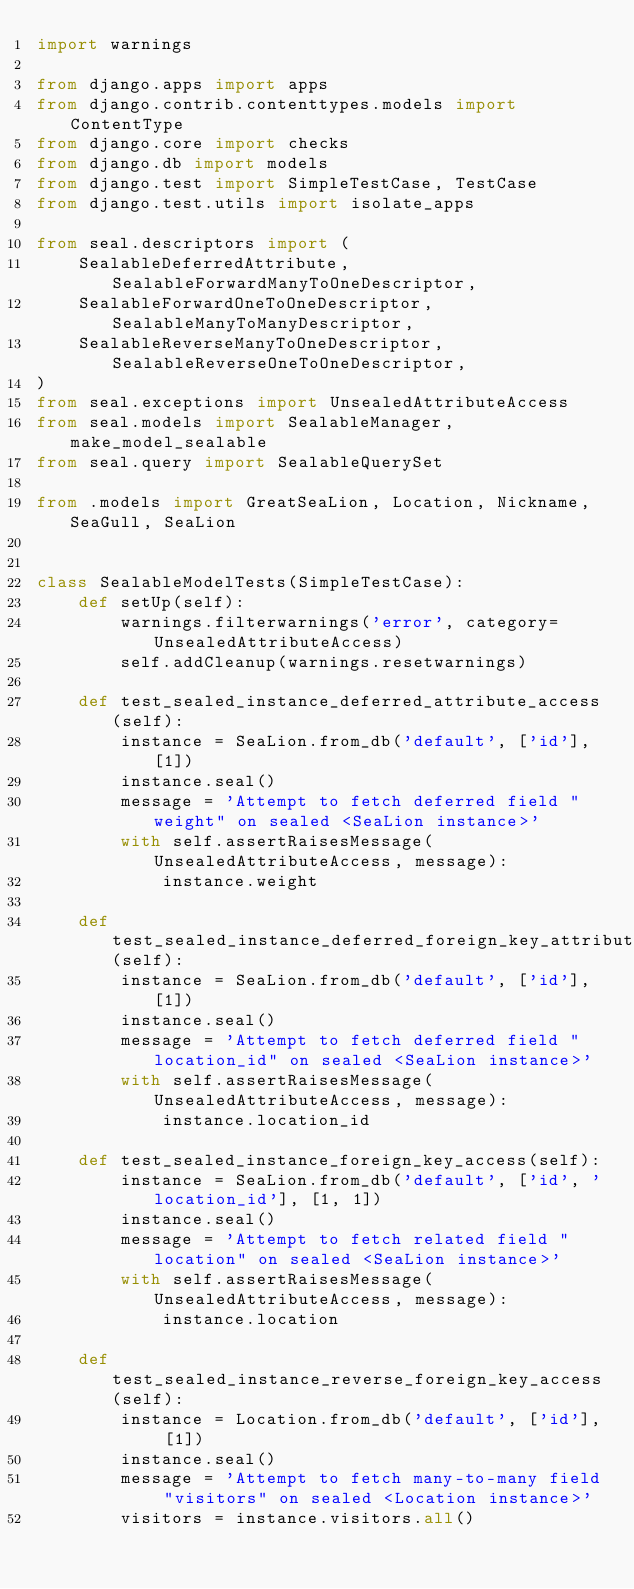<code> <loc_0><loc_0><loc_500><loc_500><_Python_>import warnings

from django.apps import apps
from django.contrib.contenttypes.models import ContentType
from django.core import checks
from django.db import models
from django.test import SimpleTestCase, TestCase
from django.test.utils import isolate_apps

from seal.descriptors import (
    SealableDeferredAttribute, SealableForwardManyToOneDescriptor,
    SealableForwardOneToOneDescriptor, SealableManyToManyDescriptor,
    SealableReverseManyToOneDescriptor, SealableReverseOneToOneDescriptor,
)
from seal.exceptions import UnsealedAttributeAccess
from seal.models import SealableManager, make_model_sealable
from seal.query import SealableQuerySet

from .models import GreatSeaLion, Location, Nickname, SeaGull, SeaLion


class SealableModelTests(SimpleTestCase):
    def setUp(self):
        warnings.filterwarnings('error', category=UnsealedAttributeAccess)
        self.addCleanup(warnings.resetwarnings)

    def test_sealed_instance_deferred_attribute_access(self):
        instance = SeaLion.from_db('default', ['id'], [1])
        instance.seal()
        message = 'Attempt to fetch deferred field "weight" on sealed <SeaLion instance>'
        with self.assertRaisesMessage(UnsealedAttributeAccess, message):
            instance.weight

    def test_sealed_instance_deferred_foreign_key_attribute_access(self):
        instance = SeaLion.from_db('default', ['id'], [1])
        instance.seal()
        message = 'Attempt to fetch deferred field "location_id" on sealed <SeaLion instance>'
        with self.assertRaisesMessage(UnsealedAttributeAccess, message):
            instance.location_id

    def test_sealed_instance_foreign_key_access(self):
        instance = SeaLion.from_db('default', ['id', 'location_id'], [1, 1])
        instance.seal()
        message = 'Attempt to fetch related field "location" on sealed <SeaLion instance>'
        with self.assertRaisesMessage(UnsealedAttributeAccess, message):
            instance.location

    def test_sealed_instance_reverse_foreign_key_access(self):
        instance = Location.from_db('default', ['id'], [1])
        instance.seal()
        message = 'Attempt to fetch many-to-many field "visitors" on sealed <Location instance>'
        visitors = instance.visitors.all()</code> 